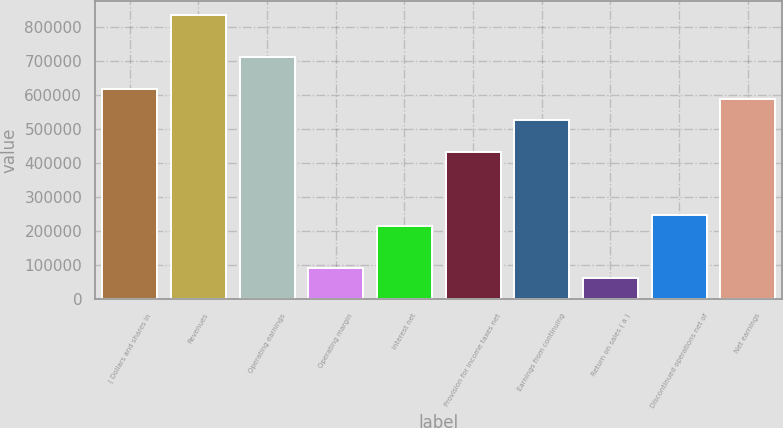<chart> <loc_0><loc_0><loc_500><loc_500><bar_chart><fcel>( Dollars and shares in<fcel>Revenues<fcel>Operating earnings<fcel>Operating margin<fcel>Interest net<fcel>Provision for income taxes net<fcel>Earnings from continuing<fcel>Return on sales ( a )<fcel>Discontinued operations net of<fcel>Net earnings<nl><fcel>618599<fcel>835108<fcel>711389<fcel>92790.6<fcel>216510<fcel>433020<fcel>525809<fcel>61860.7<fcel>247440<fcel>587669<nl></chart> 